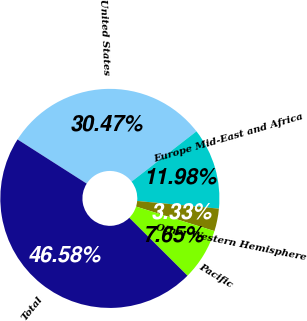Convert chart. <chart><loc_0><loc_0><loc_500><loc_500><pie_chart><fcel>United States<fcel>Europe Mid-East and Africa<fcel>Other Western Hemisphere<fcel>Pacific<fcel>Total<nl><fcel>30.47%<fcel>11.98%<fcel>3.33%<fcel>7.65%<fcel>46.58%<nl></chart> 